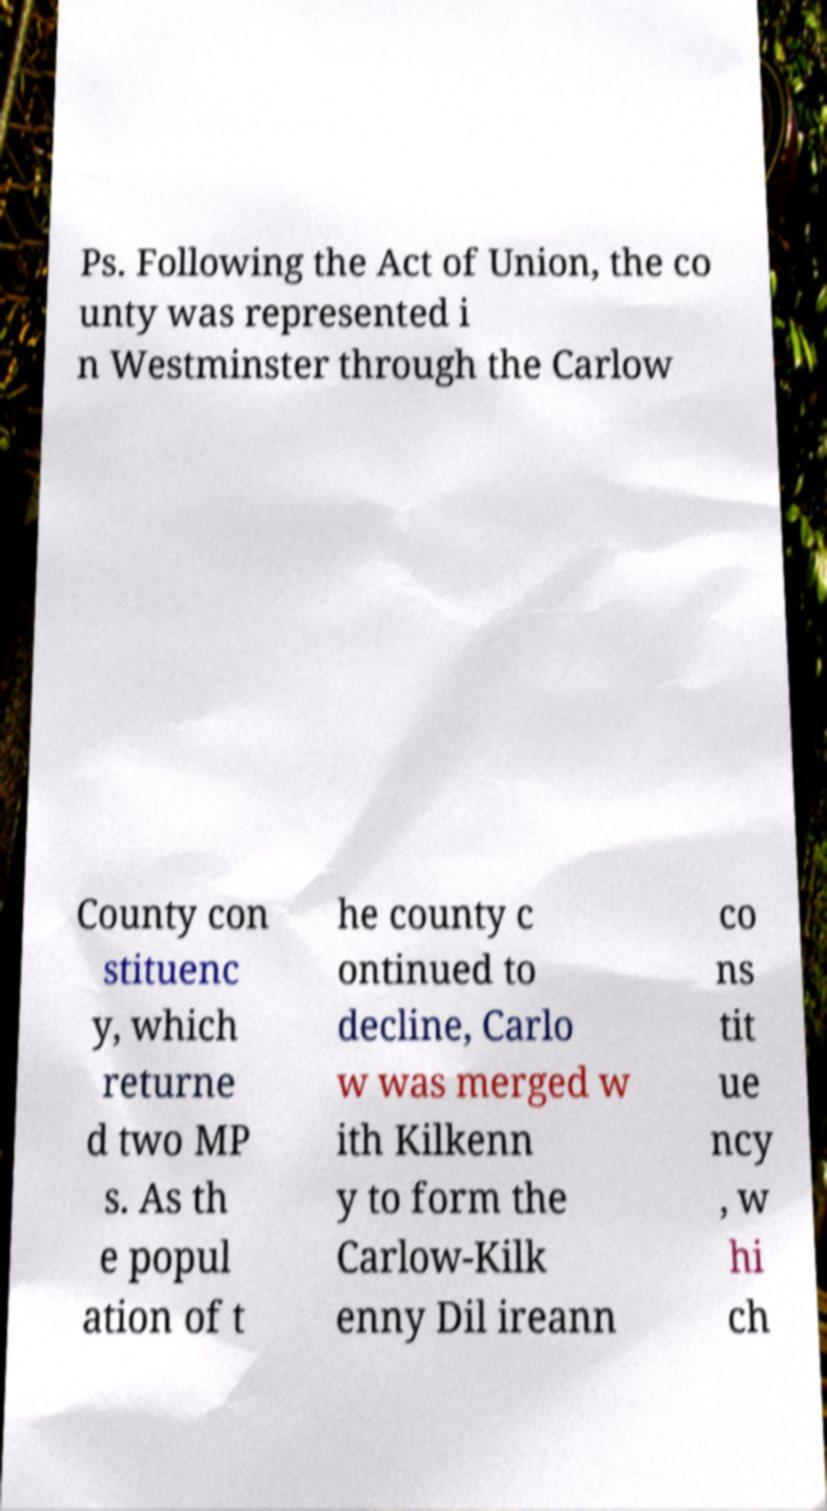I need the written content from this picture converted into text. Can you do that? Ps. Following the Act of Union, the co unty was represented i n Westminster through the Carlow County con stituenc y, which returne d two MP s. As th e popul ation of t he county c ontinued to decline, Carlo w was merged w ith Kilkenn y to form the Carlow-Kilk enny Dil ireann co ns tit ue ncy , w hi ch 